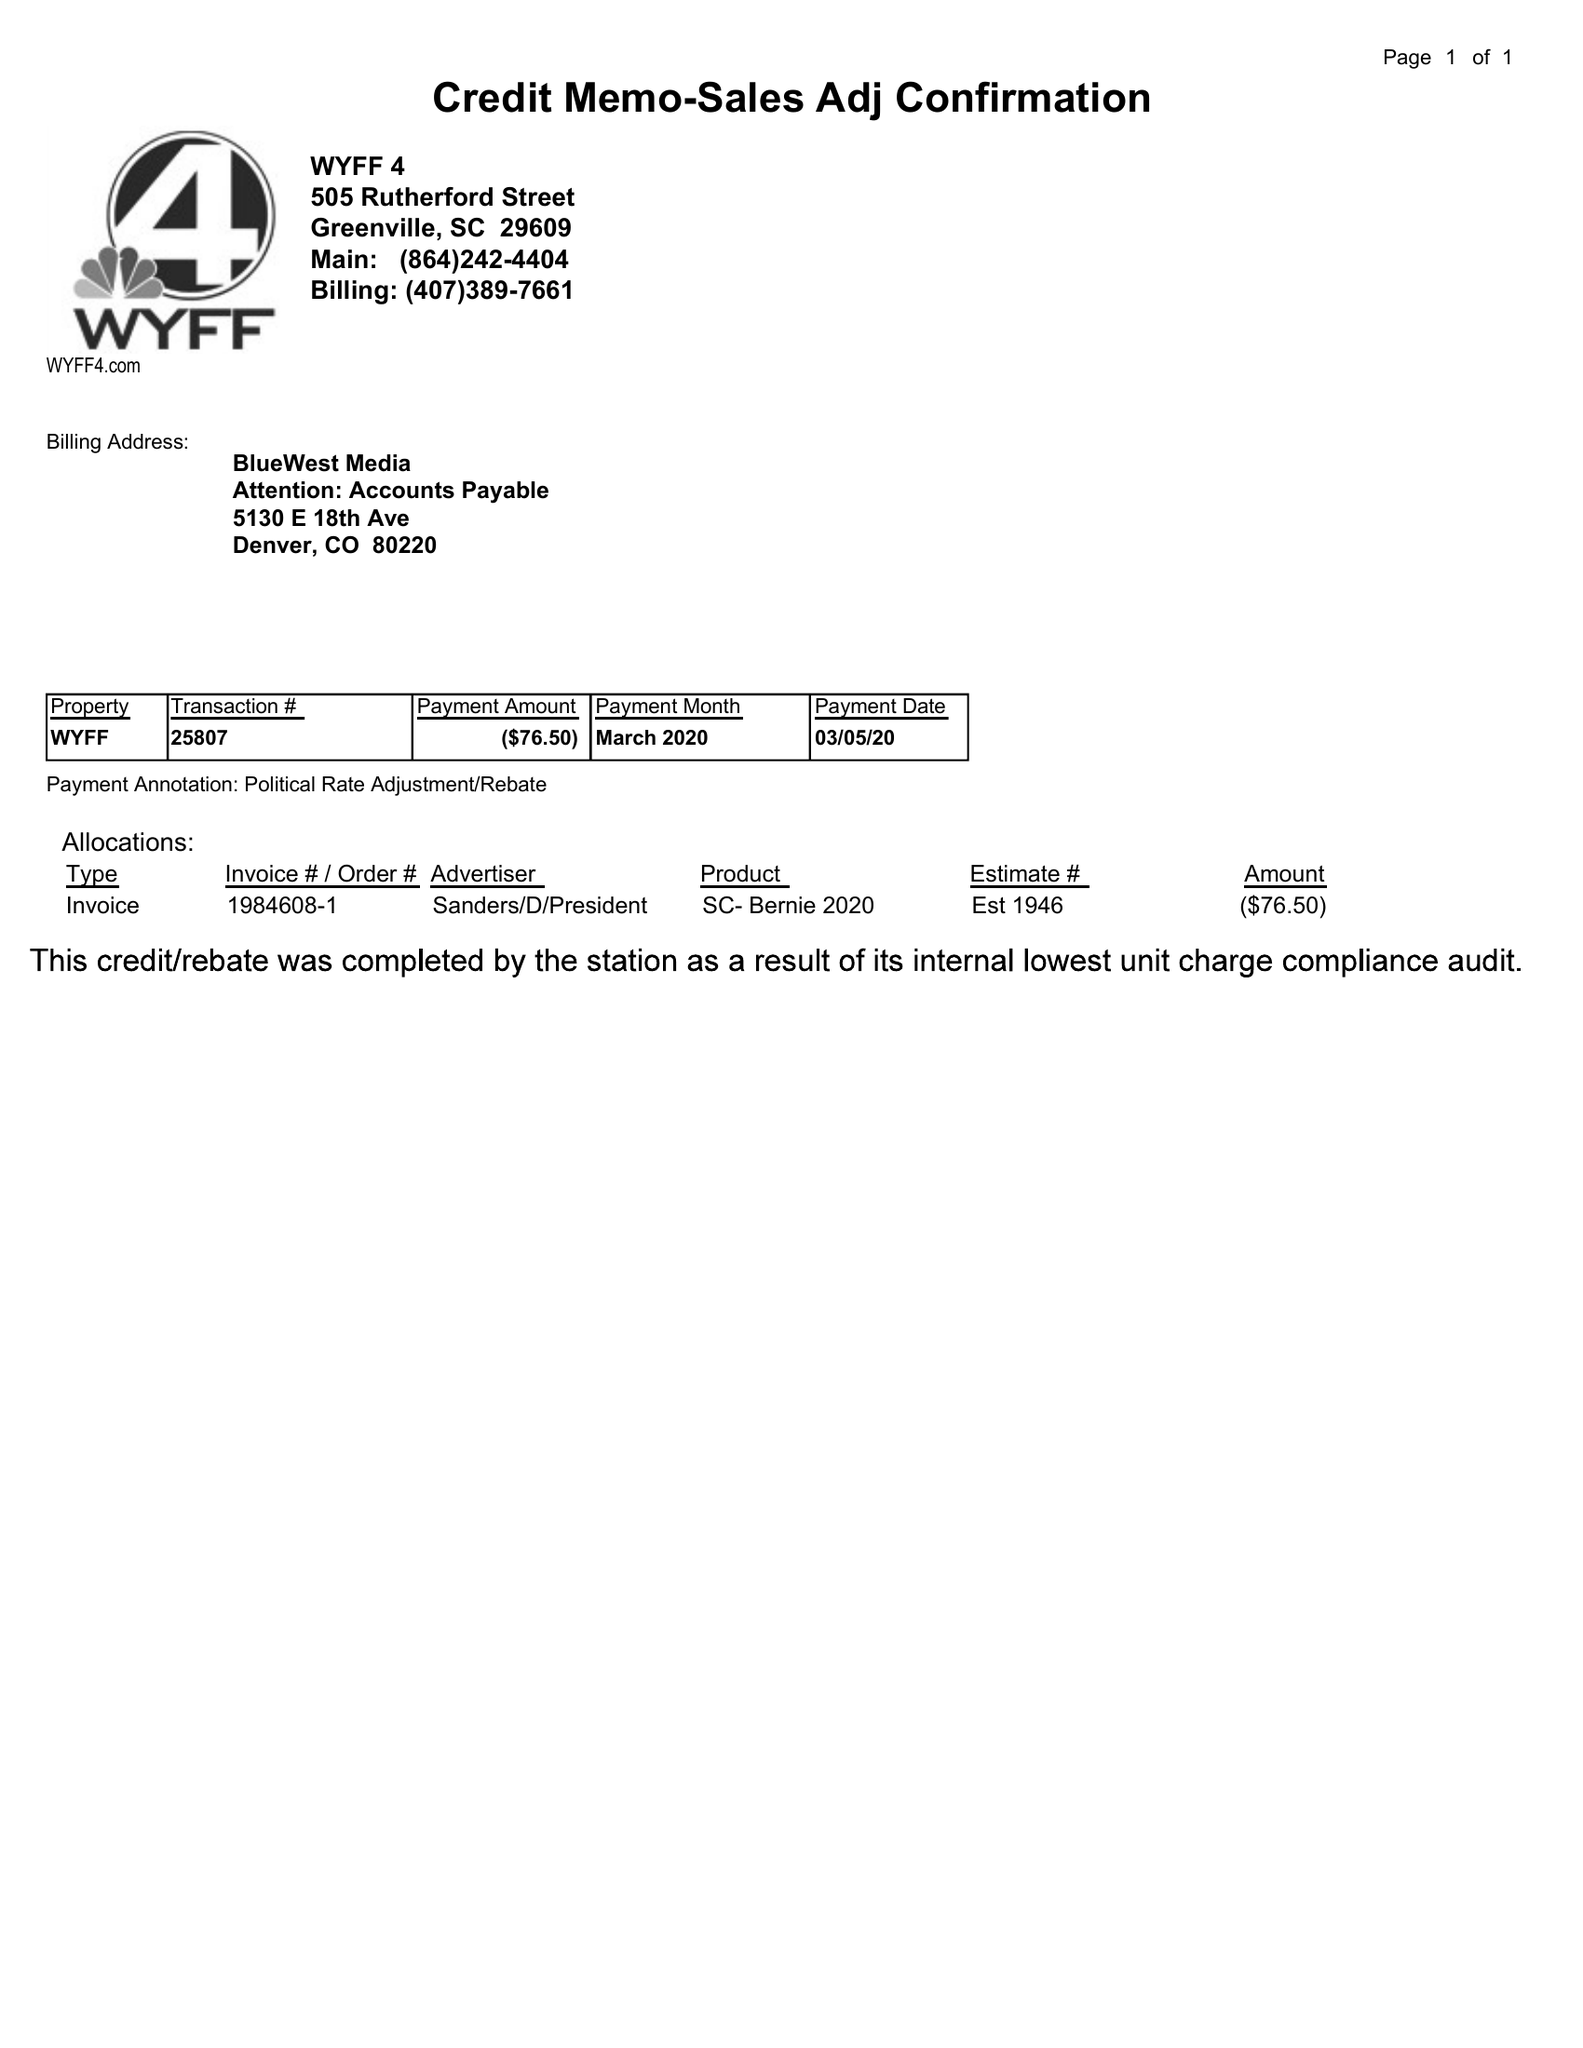What is the value for the contract_num?
Answer the question using a single word or phrase. 1984608 